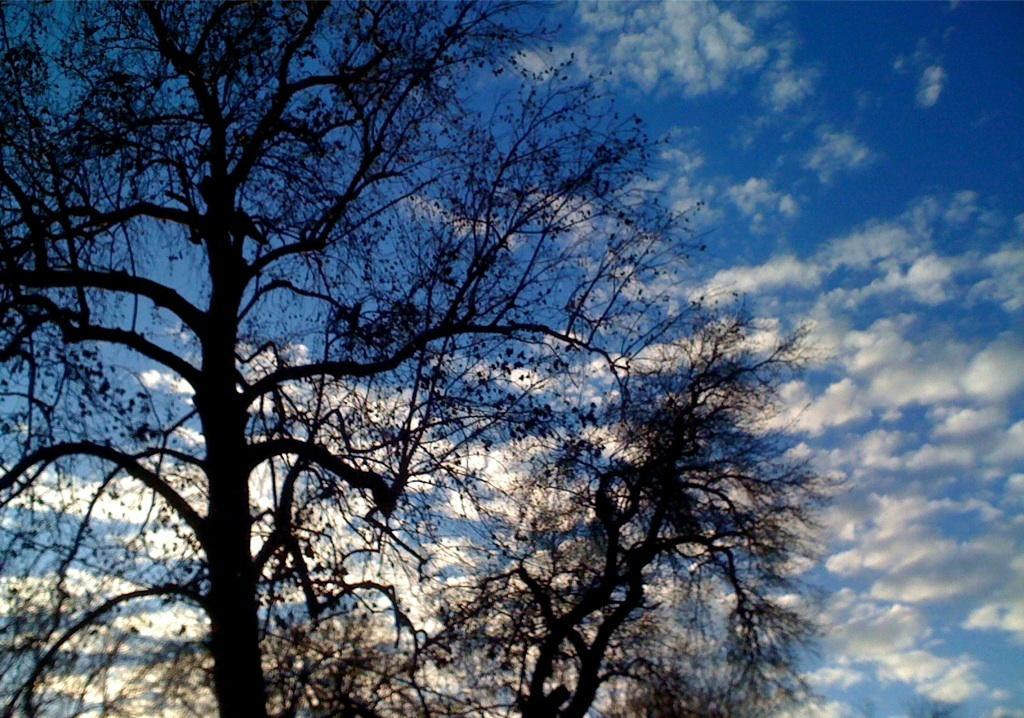How many trees can be seen in the image? There are two trees in the image. What is visible in the background of the image? There is a sky visible in the background of the image. What can be observed about the sky in the image? The sky contains many clouds. What type of respect can be seen being shown in the image? There is no indication of respect being shown in the image, as it primarily features trees and a cloudy sky. 